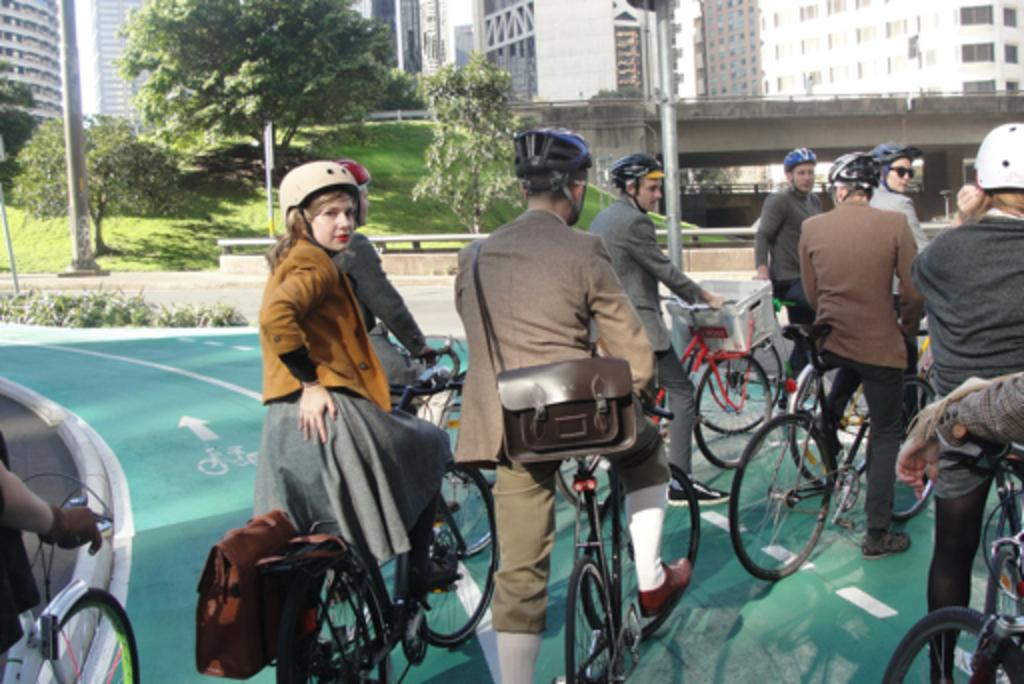What are the people in the image wearing on their heads? The people in the image are wearing helmets. What are the people sitting on in the image? The people are sitting on bicycles. What type of structure can be seen in the image? There is a building in the image. What type of vegetation is present in the image? There are trees in the image. How does the digestion process work for the trees in the image? The trees in the image do not have a digestion process, as they are plants and not living organisms with digestive systems. 